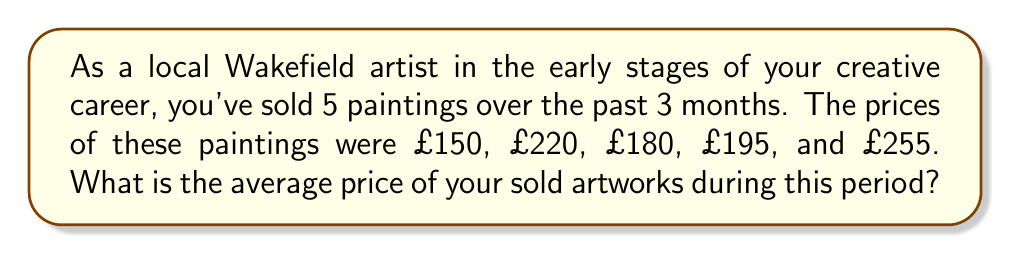Help me with this question. To find the average price of the sold artworks, we need to:

1. Add up the prices of all sold paintings
2. Divide the sum by the number of paintings sold

Let's go through this step-by-step:

1. Sum of prices:
   $$150 + 220 + 180 + 195 + 255 = 1000$$

2. Number of paintings sold: 5

3. Calculate the average:
   $$\text{Average} = \frac{\text{Sum of prices}}{\text{Number of paintings}}$$
   
   $$\text{Average} = \frac{1000}{5} = 200$$

Therefore, the average price of your sold artworks over this 3-month period is £200.
Answer: £200 